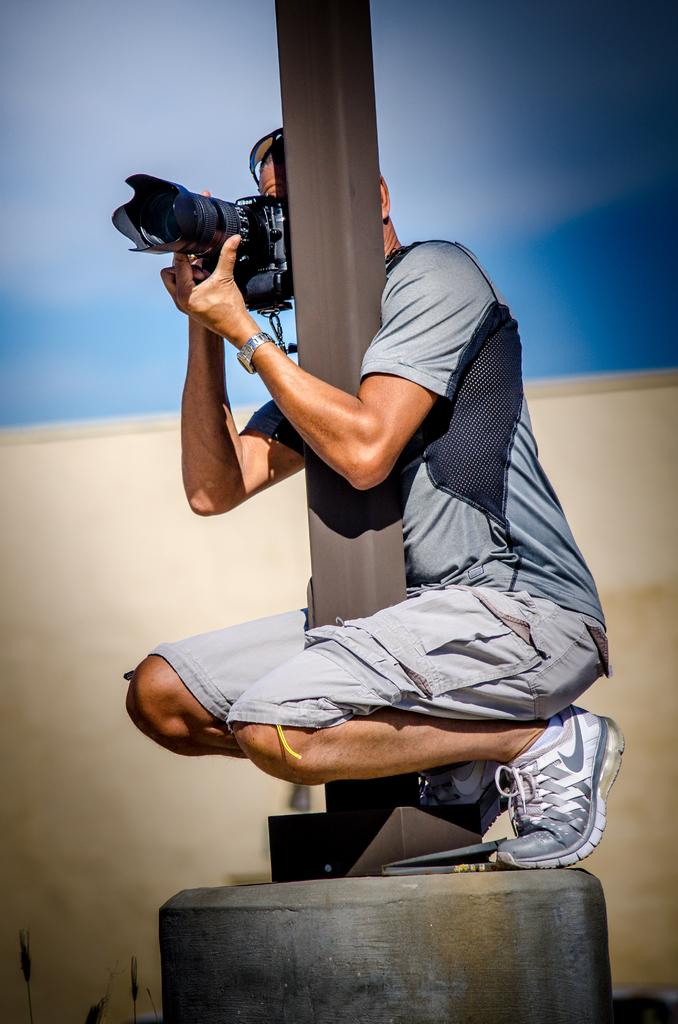What is the main subject of the image? There is a person in the image. Can you describe the person's clothing? The person is wearing a short and T-shirt. What is the person holding in their hands? The person is holding a camera in their hands. How is the person positioned in the image? The person is crouching down on a pole. What type of star can be seen in the image? There is no star visible in the image; it features a person holding a camera while crouching on a pole. What color is the slip the person is wearing in the image? The person is not wearing a slip in the image; they are wearing a short and T-shirt. 